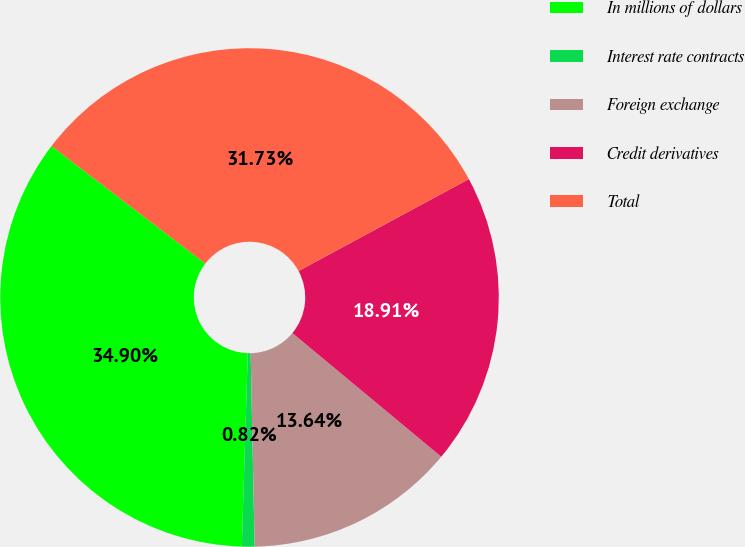Convert chart to OTSL. <chart><loc_0><loc_0><loc_500><loc_500><pie_chart><fcel>In millions of dollars<fcel>Interest rate contracts<fcel>Foreign exchange<fcel>Credit derivatives<fcel>Total<nl><fcel>34.9%<fcel>0.82%<fcel>13.64%<fcel>18.91%<fcel>31.73%<nl></chart> 